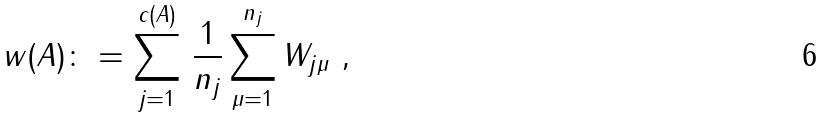<formula> <loc_0><loc_0><loc_500><loc_500>w ( A ) \colon = \sum _ { j = 1 } ^ { c ( A ) } \, \frac { 1 } { n _ { j } } \sum _ { \mu = 1 } ^ { n _ { j } } W _ { j \mu } \ ,</formula> 